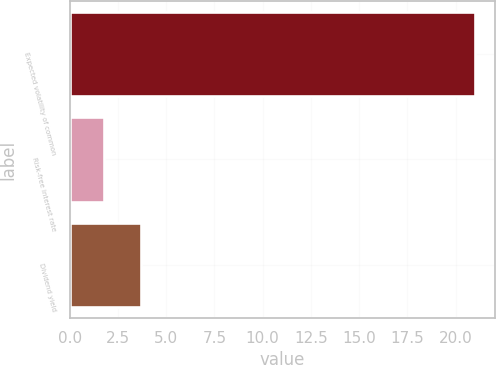Convert chart to OTSL. <chart><loc_0><loc_0><loc_500><loc_500><bar_chart><fcel>Expected volatility of common<fcel>Risk-free interest rate<fcel>Dividend yield<nl><fcel>21<fcel>1.8<fcel>3.72<nl></chart> 